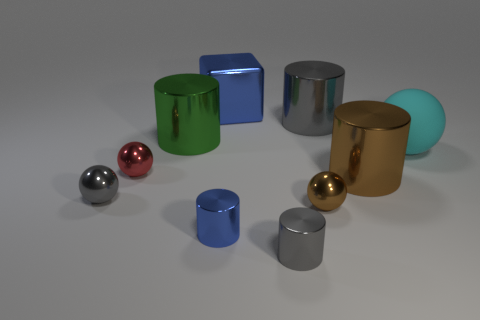There is a thing that is the same color as the shiny block; what material is it?
Your response must be concise. Metal. How many other things are there of the same color as the large shiny cube?
Your answer should be compact. 1. What number of cylinders are small purple objects or big gray objects?
Your response must be concise. 1. What color is the big cylinder on the left side of the tiny shiny object right of the small gray metallic cylinder?
Offer a very short reply. Green. The small blue metal thing is what shape?
Provide a succinct answer. Cylinder. Does the gray shiny thing left of the red sphere have the same size as the big gray shiny cylinder?
Make the answer very short. No. Are there any gray things that have the same material as the cyan sphere?
Provide a succinct answer. No. How many objects are gray metal cylinders that are behind the red object or tiny balls?
Provide a succinct answer. 4. Is there a big gray cylinder?
Offer a terse response. Yes. There is a big thing that is behind the big brown cylinder and in front of the green metal cylinder; what shape is it?
Offer a terse response. Sphere. 